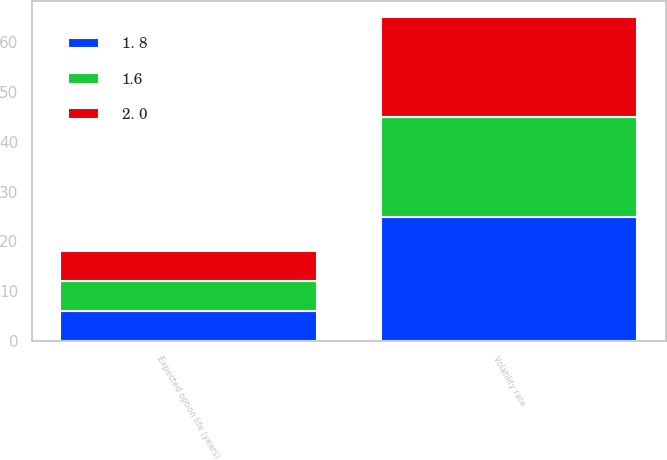Convert chart to OTSL. <chart><loc_0><loc_0><loc_500><loc_500><stacked_bar_chart><ecel><fcel>Volatility rate<fcel>Expected option life (years)<nl><fcel>2. 0<fcel>20<fcel>6<nl><fcel>1.6<fcel>20<fcel>6<nl><fcel>1. 8<fcel>25<fcel>6<nl></chart> 